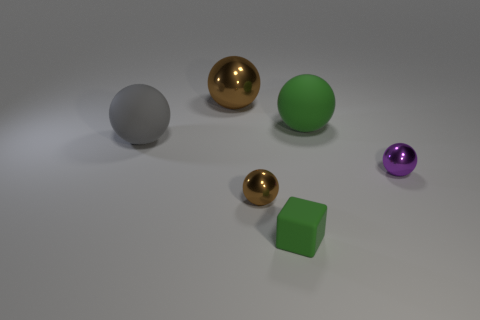How many other balls have the same size as the purple sphere?
Keep it short and to the point. 1. What number of blue things are either tiny blocks or metal spheres?
Ensure brevity in your answer.  0. What shape is the metallic object left of the brown sphere that is in front of the large green ball?
Ensure brevity in your answer.  Sphere. There is a green rubber thing that is the same size as the purple ball; what shape is it?
Your answer should be very brief. Cube. Is there a matte ball of the same color as the small matte block?
Provide a succinct answer. Yes. Is the number of small metal objects that are in front of the purple sphere the same as the number of brown objects that are on the right side of the small matte block?
Offer a very short reply. No. Does the gray rubber thing have the same shape as the shiny object in front of the small purple shiny object?
Your answer should be very brief. Yes. How many other things are there of the same material as the gray sphere?
Your answer should be very brief. 2. Are there any small green matte blocks in front of the big green thing?
Offer a terse response. Yes. There is a gray matte object; does it have the same size as the brown ball on the right side of the big metal sphere?
Your response must be concise. No. 